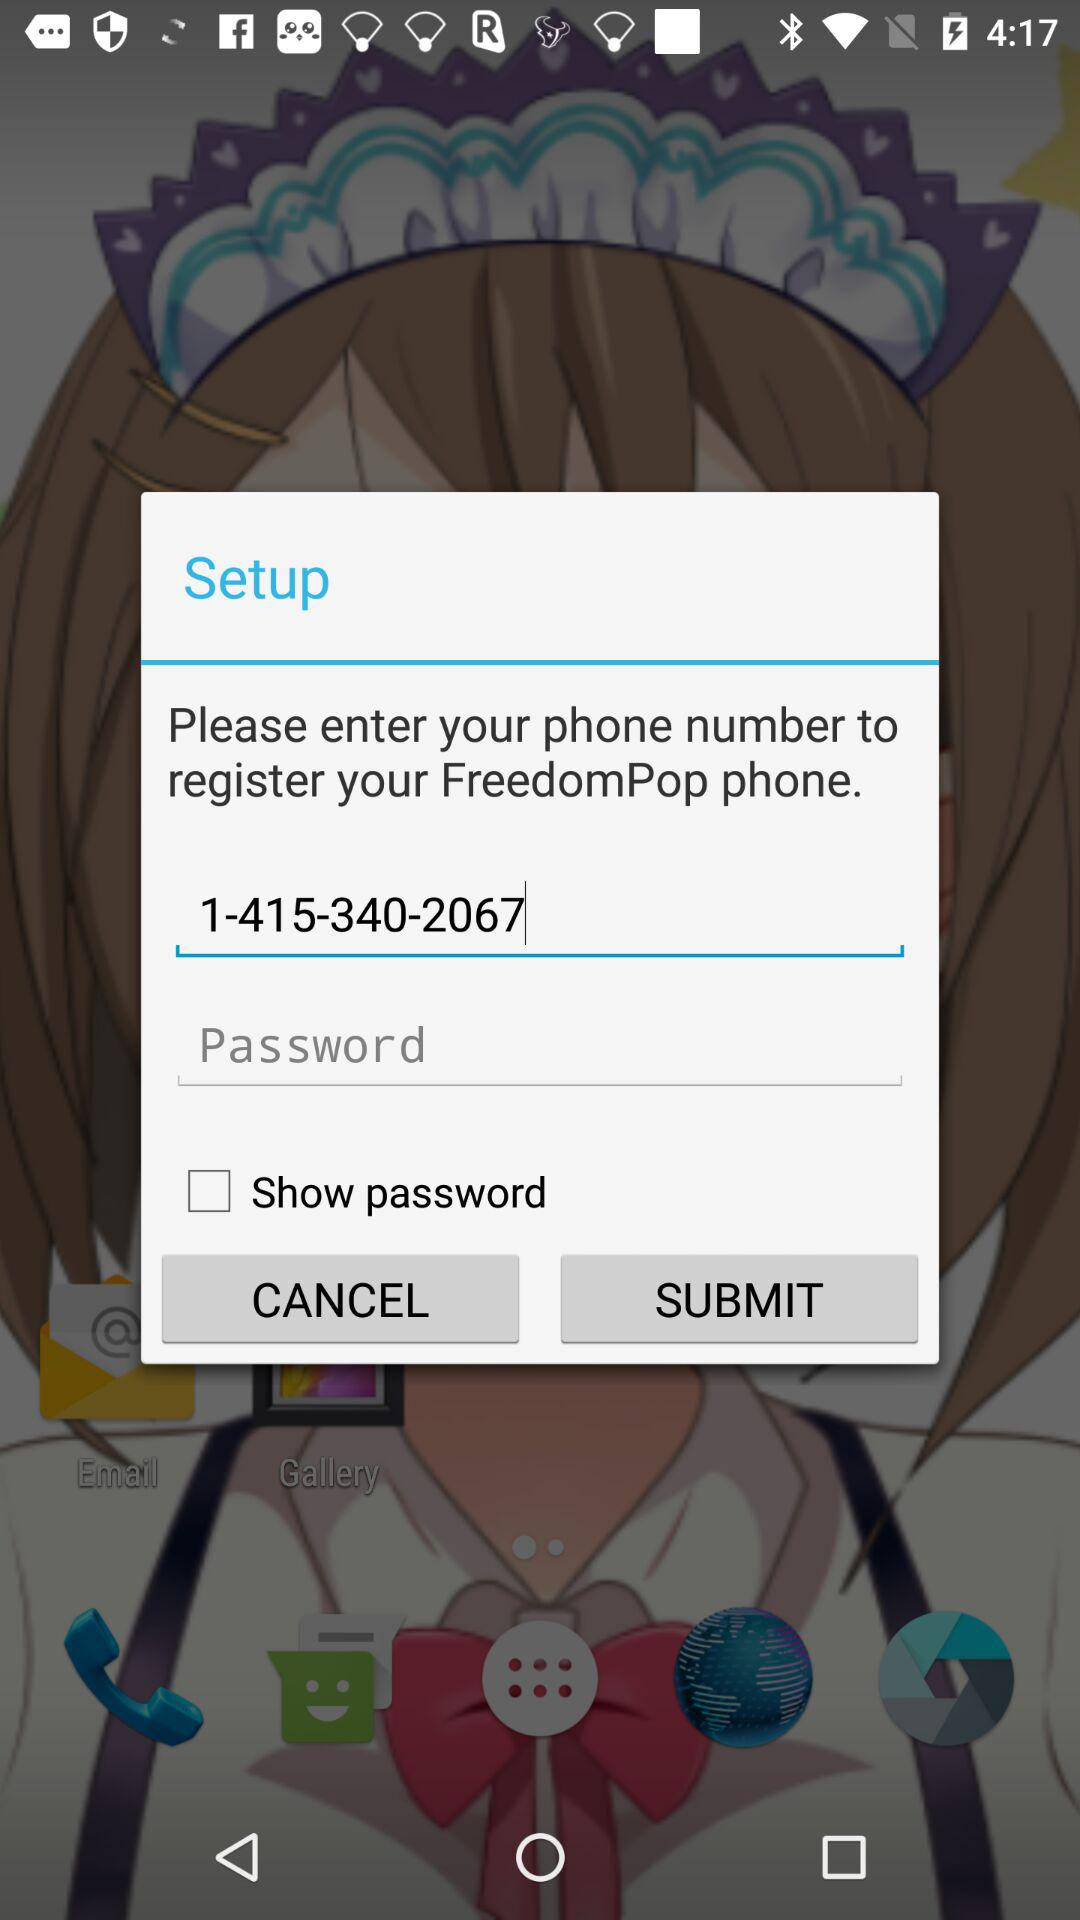What's the status of "Show password"? The status is "off". 